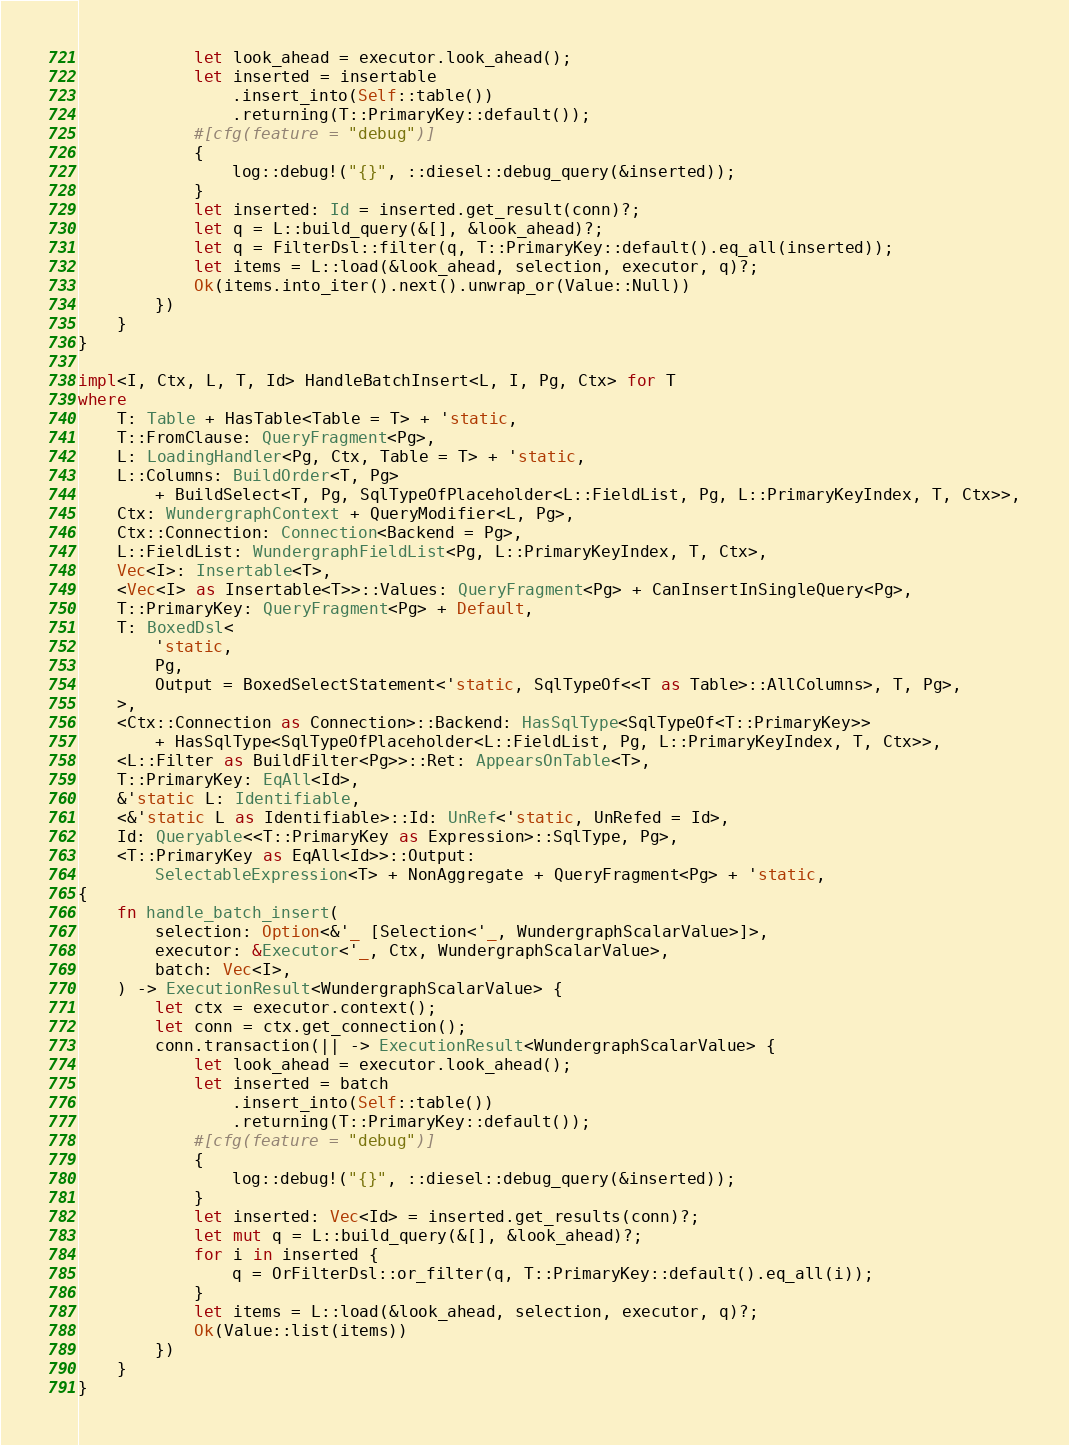Convert code to text. <code><loc_0><loc_0><loc_500><loc_500><_Rust_>            let look_ahead = executor.look_ahead();
            let inserted = insertable
                .insert_into(Self::table())
                .returning(T::PrimaryKey::default());
            #[cfg(feature = "debug")]
            {
                log::debug!("{}", ::diesel::debug_query(&inserted));
            }
            let inserted: Id = inserted.get_result(conn)?;
            let q = L::build_query(&[], &look_ahead)?;
            let q = FilterDsl::filter(q, T::PrimaryKey::default().eq_all(inserted));
            let items = L::load(&look_ahead, selection, executor, q)?;
            Ok(items.into_iter().next().unwrap_or(Value::Null))
        })
    }
}

impl<I, Ctx, L, T, Id> HandleBatchInsert<L, I, Pg, Ctx> for T
where
    T: Table + HasTable<Table = T> + 'static,
    T::FromClause: QueryFragment<Pg>,
    L: LoadingHandler<Pg, Ctx, Table = T> + 'static,
    L::Columns: BuildOrder<T, Pg>
        + BuildSelect<T, Pg, SqlTypeOfPlaceholder<L::FieldList, Pg, L::PrimaryKeyIndex, T, Ctx>>,
    Ctx: WundergraphContext + QueryModifier<L, Pg>,
    Ctx::Connection: Connection<Backend = Pg>,
    L::FieldList: WundergraphFieldList<Pg, L::PrimaryKeyIndex, T, Ctx>,
    Vec<I>: Insertable<T>,
    <Vec<I> as Insertable<T>>::Values: QueryFragment<Pg> + CanInsertInSingleQuery<Pg>,
    T::PrimaryKey: QueryFragment<Pg> + Default,
    T: BoxedDsl<
        'static,
        Pg,
        Output = BoxedSelectStatement<'static, SqlTypeOf<<T as Table>::AllColumns>, T, Pg>,
    >,
    <Ctx::Connection as Connection>::Backend: HasSqlType<SqlTypeOf<T::PrimaryKey>>
        + HasSqlType<SqlTypeOfPlaceholder<L::FieldList, Pg, L::PrimaryKeyIndex, T, Ctx>>,
    <L::Filter as BuildFilter<Pg>>::Ret: AppearsOnTable<T>,
    T::PrimaryKey: EqAll<Id>,
    &'static L: Identifiable,
    <&'static L as Identifiable>::Id: UnRef<'static, UnRefed = Id>,
    Id: Queryable<<T::PrimaryKey as Expression>::SqlType, Pg>,
    <T::PrimaryKey as EqAll<Id>>::Output:
        SelectableExpression<T> + NonAggregate + QueryFragment<Pg> + 'static,
{
    fn handle_batch_insert(
        selection: Option<&'_ [Selection<'_, WundergraphScalarValue>]>,
        executor: &Executor<'_, Ctx, WundergraphScalarValue>,
        batch: Vec<I>,
    ) -> ExecutionResult<WundergraphScalarValue> {
        let ctx = executor.context();
        let conn = ctx.get_connection();
        conn.transaction(|| -> ExecutionResult<WundergraphScalarValue> {
            let look_ahead = executor.look_ahead();
            let inserted = batch
                .insert_into(Self::table())
                .returning(T::PrimaryKey::default());
            #[cfg(feature = "debug")]
            {
                log::debug!("{}", ::diesel::debug_query(&inserted));
            }
            let inserted: Vec<Id> = inserted.get_results(conn)?;
            let mut q = L::build_query(&[], &look_ahead)?;
            for i in inserted {
                q = OrFilterDsl::or_filter(q, T::PrimaryKey::default().eq_all(i));
            }
            let items = L::load(&look_ahead, selection, executor, q)?;
            Ok(Value::list(items))
        })
    }
}
</code> 